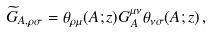Convert formula to latex. <formula><loc_0><loc_0><loc_500><loc_500>\widetilde { G } _ { A , \rho \sigma } = \theta _ { \rho \mu } ( A ; z ) G _ { A } ^ { \mu \nu } \theta _ { \nu \sigma } ( A ; z ) \, ,</formula> 